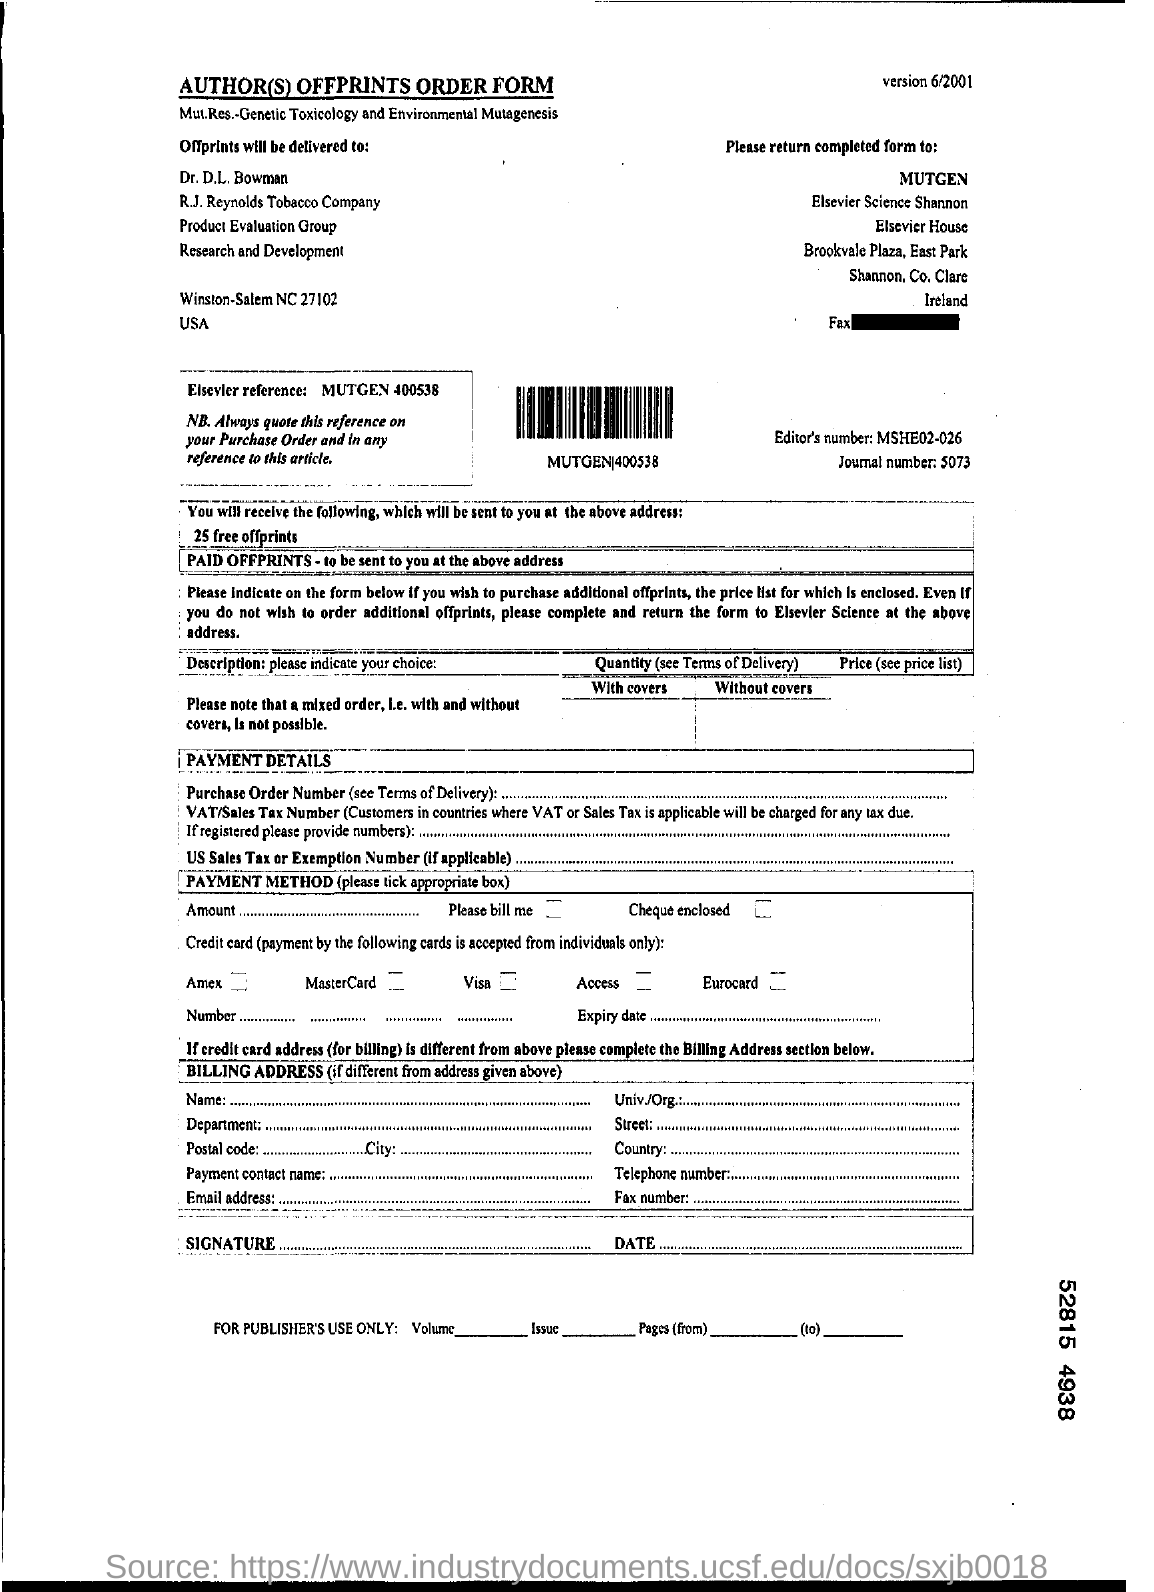What is Editor's number ?
Ensure brevity in your answer.  MSHE02-026. What is Journal number?
Provide a short and direct response. 5073. To whom the offprints will be delivered?
Your answer should be very brief. Dr. D.L. Bowman. 